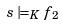Convert formula to latex. <formula><loc_0><loc_0><loc_500><loc_500>s \models _ { K } f _ { 2 }</formula> 